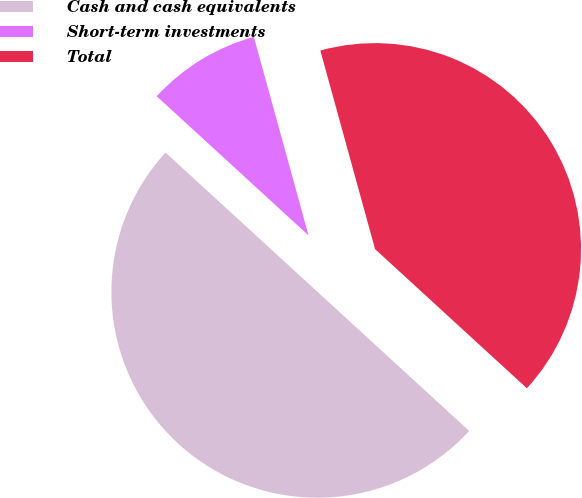<chart> <loc_0><loc_0><loc_500><loc_500><pie_chart><fcel>Cash and cash equivalents<fcel>Short-term investments<fcel>Total<nl><fcel>50.0%<fcel>8.91%<fcel>41.09%<nl></chart> 